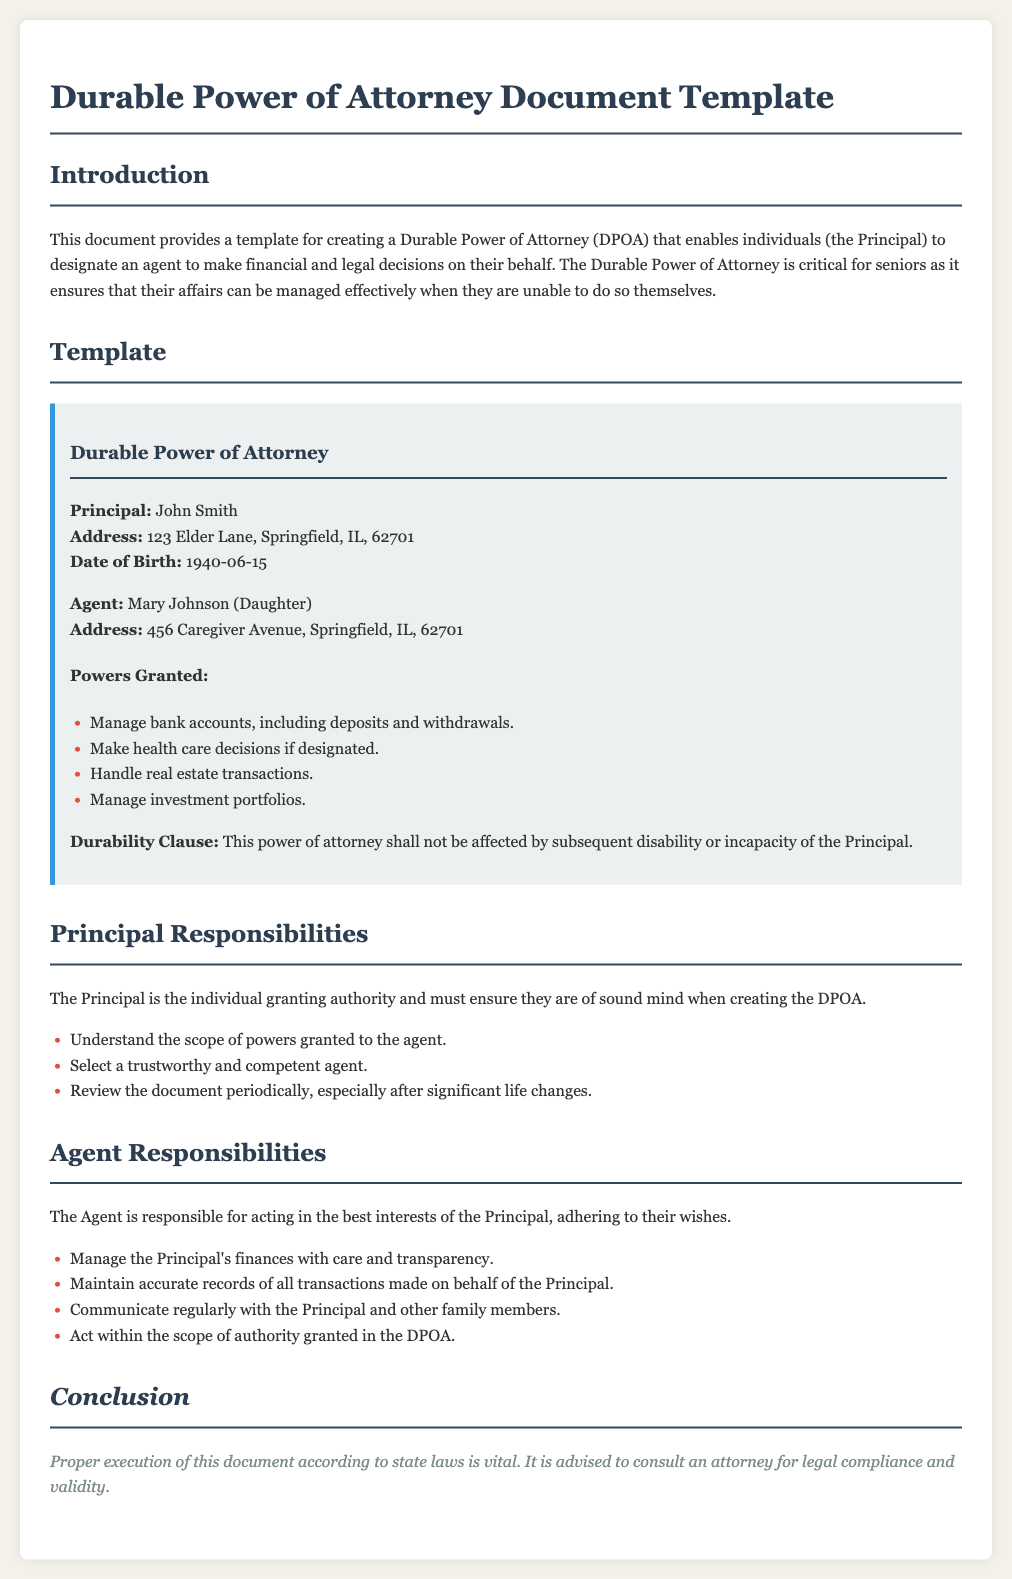What is the name of the Principal? The Principal is the individual granting authority, whose name is stated in the document.
Answer: John Smith What is the address of the Agent? The address of the Agent, Mary Johnson, is specifically mentioned in the document.
Answer: 456 Caregiver Avenue, Springfield, IL, 62701 What powers are granted to the Agent? The document includes a list of powers granted to the Agent, highlighting their main responsibilities.
Answer: Manage bank accounts, make health care decisions, handle real estate transactions, manage investment portfolios What is the date of birth of the Principal? The date of birth of the Principal is explicitly provided in the document for identification.
Answer: 1940-06-15 What type of document is this? The title of the document outlines its purpose and legal function.
Answer: Durable Power of Attorney What is the durability clause? The durability clause clarifies the document’s durability in relation to the Principal's capacity.
Answer: This power of attorney shall not be affected by subsequent disability or incapacity of the Principal What are the Principal's responsibilities? The responsibilities of the Principal are specifically enumerated in the document, highlighting their role in the DPOA.
Answer: Understand the scope of powers granted, select a trustworthy agent, review the document regularly What should the Agent maintain? The Agent's responsibilities include a specific requirement related to financial documentation.
Answer: Accurate records of all transactions made on behalf of the Principal 